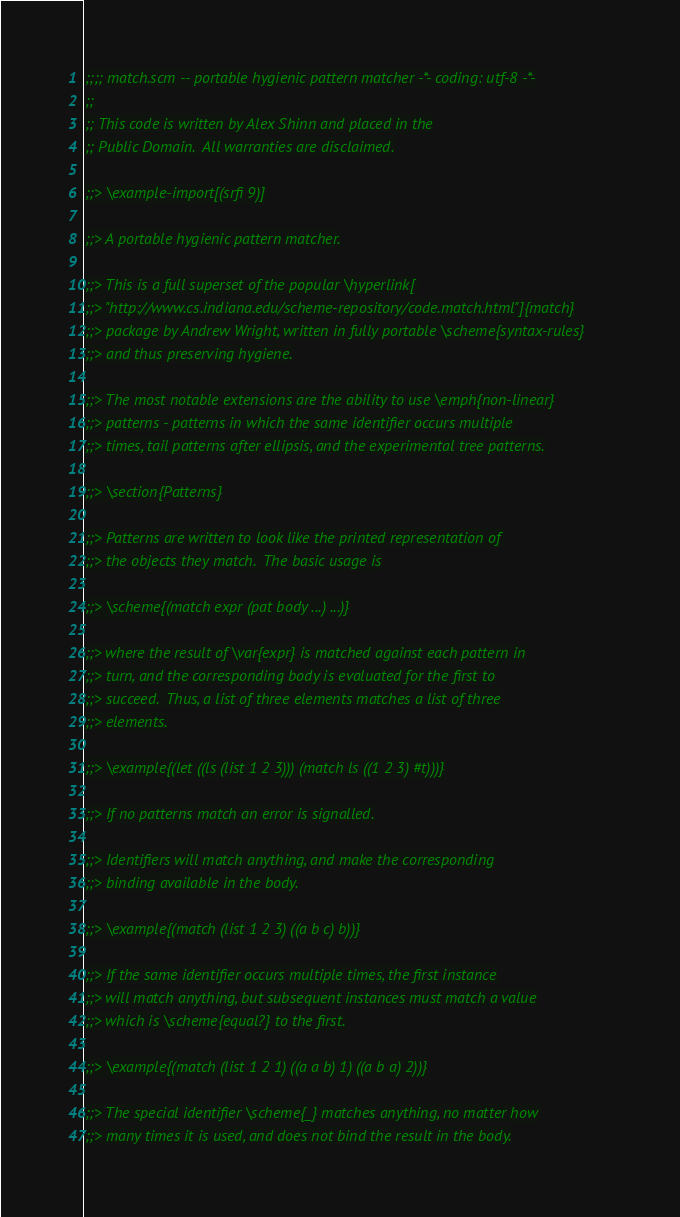Convert code to text. <code><loc_0><loc_0><loc_500><loc_500><_Scheme_>;;;; match.scm -- portable hygienic pattern matcher -*- coding: utf-8 -*-
;;
;; This code is written by Alex Shinn and placed in the
;; Public Domain.  All warranties are disclaimed.

;;> \example-import[(srfi 9)]

;;> A portable hygienic pattern matcher.

;;> This is a full superset of the popular \hyperlink[
;;> "http://www.cs.indiana.edu/scheme-repository/code.match.html"]{match}
;;> package by Andrew Wright, written in fully portable \scheme{syntax-rules}
;;> and thus preserving hygiene.

;;> The most notable extensions are the ability to use \emph{non-linear}
;;> patterns - patterns in which the same identifier occurs multiple
;;> times, tail patterns after ellipsis, and the experimental tree patterns.

;;> \section{Patterns}

;;> Patterns are written to look like the printed representation of
;;> the objects they match.  The basic usage is

;;> \scheme{(match expr (pat body ...) ...)}

;;> where the result of \var{expr} is matched against each pattern in
;;> turn, and the corresponding body is evaluated for the first to
;;> succeed.  Thus, a list of three elements matches a list of three
;;> elements.

;;> \example{(let ((ls (list 1 2 3))) (match ls ((1 2 3) #t)))}

;;> If no patterns match an error is signalled.

;;> Identifiers will match anything, and make the corresponding
;;> binding available in the body.

;;> \example{(match (list 1 2 3) ((a b c) b))}

;;> If the same identifier occurs multiple times, the first instance
;;> will match anything, but subsequent instances must match a value
;;> which is \scheme{equal?} to the first.

;;> \example{(match (list 1 2 1) ((a a b) 1) ((a b a) 2))}

;;> The special identifier \scheme{_} matches anything, no matter how
;;> many times it is used, and does not bind the result in the body.
</code> 